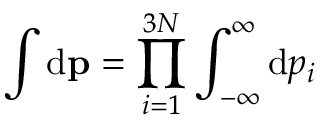Convert formula to latex. <formula><loc_0><loc_0><loc_500><loc_500>\int { d } { p } = \prod _ { i = 1 } ^ { 3 N } \int _ { - \infty } ^ { \infty } { d } p _ { i }</formula> 